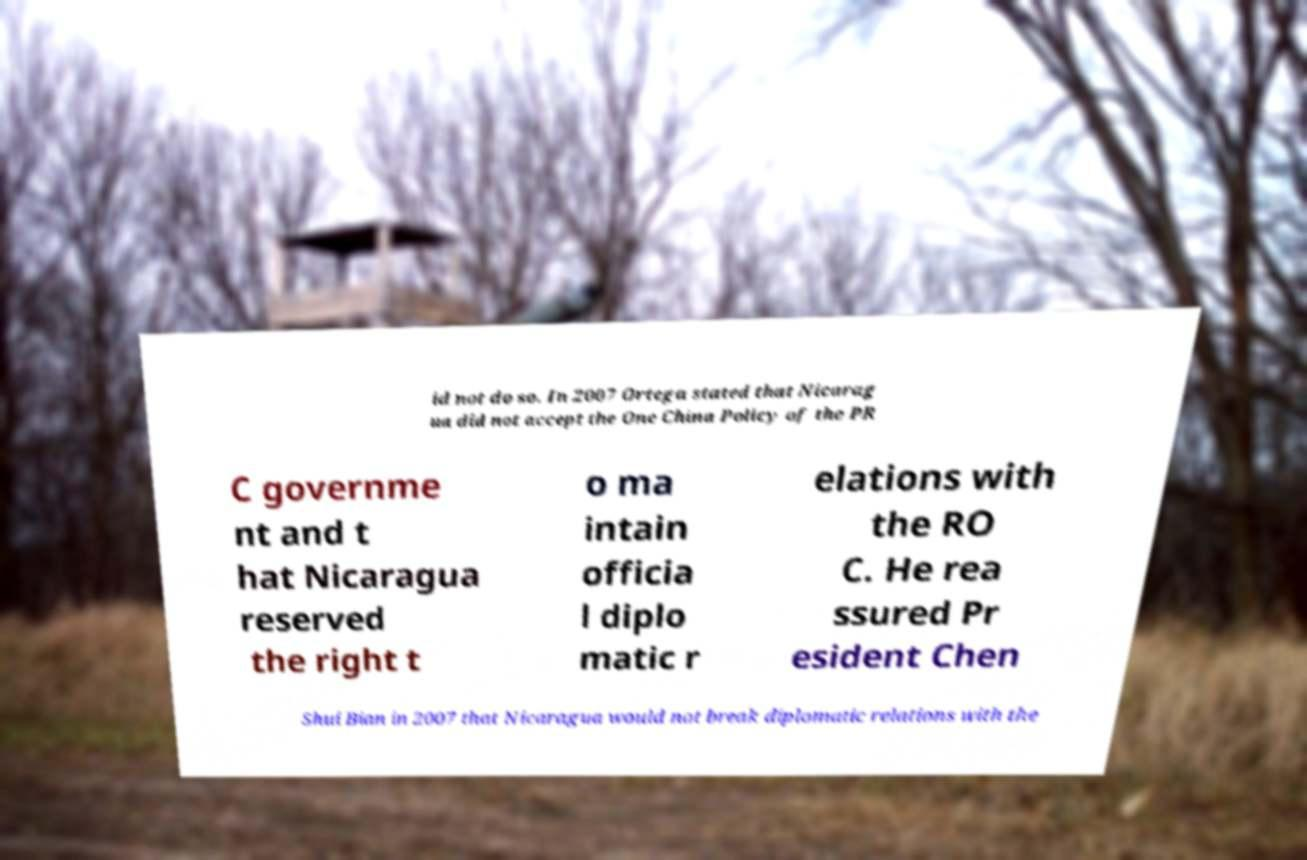Can you read and provide the text displayed in the image?This photo seems to have some interesting text. Can you extract and type it out for me? id not do so. In 2007 Ortega stated that Nicarag ua did not accept the One China Policy of the PR C governme nt and t hat Nicaragua reserved the right t o ma intain officia l diplo matic r elations with the RO C. He rea ssured Pr esident Chen Shui Bian in 2007 that Nicaragua would not break diplomatic relations with the 